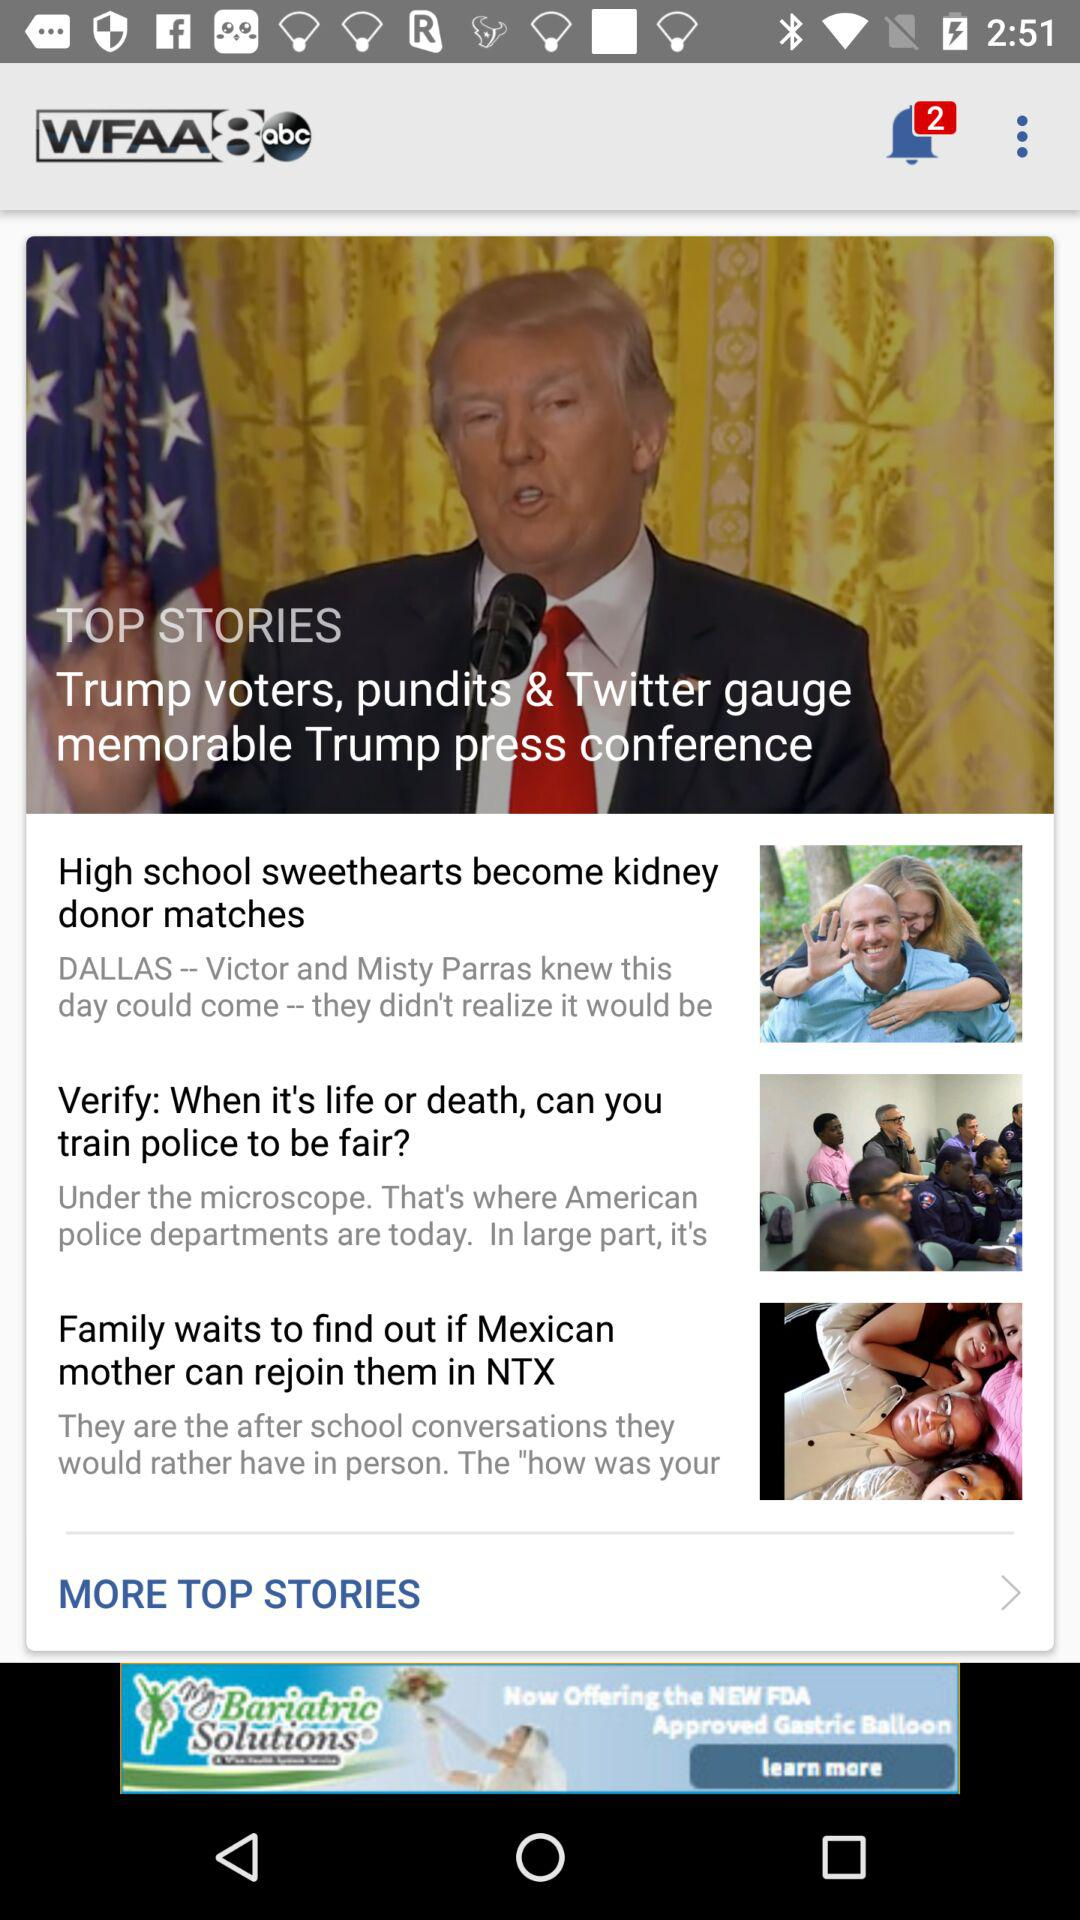How many stories are on the screen?
Answer the question using a single word or phrase. 3 